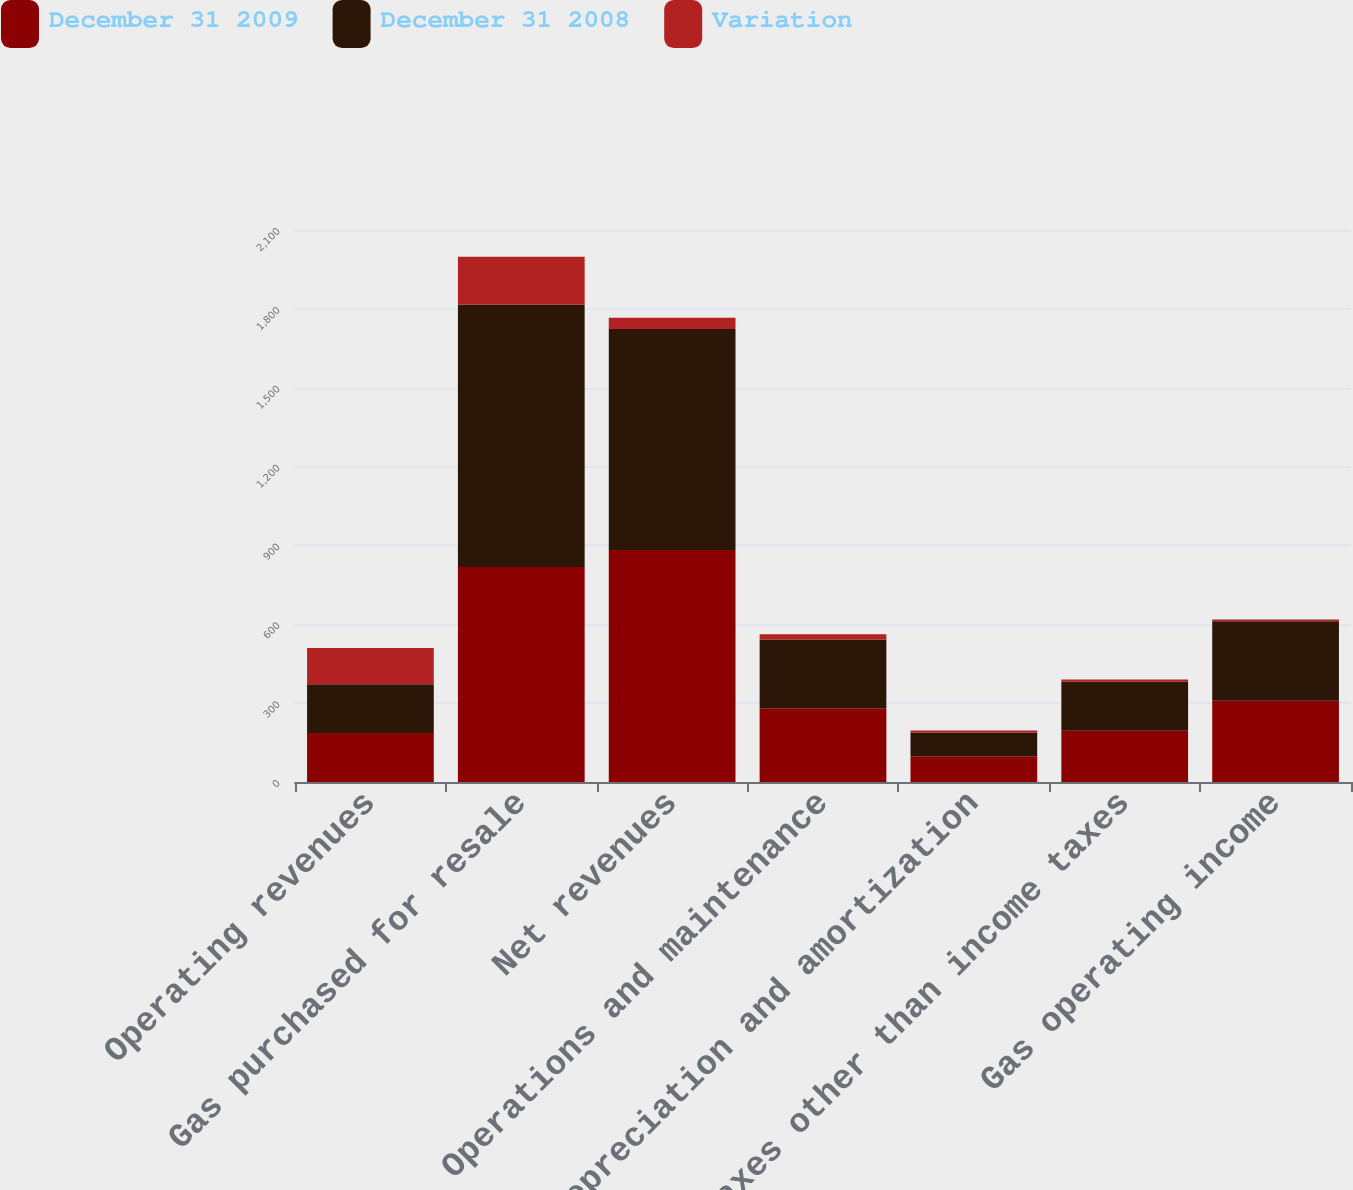Convert chart to OTSL. <chart><loc_0><loc_0><loc_500><loc_500><stacked_bar_chart><ecel><fcel>Operating revenues<fcel>Gas purchased for resale<fcel>Net revenues<fcel>Operations and maintenance<fcel>Depreciation and amortization<fcel>Taxes other than income taxes<fcel>Gas operating income<nl><fcel>December 31 2009<fcel>186<fcel>818<fcel>883<fcel>281<fcel>98<fcel>195<fcel>309<nl><fcel>December 31 2008<fcel>186<fcel>999<fcel>840<fcel>261<fcel>90<fcel>186<fcel>303<nl><fcel>Variation<fcel>138<fcel>181<fcel>43<fcel>20<fcel>8<fcel>9<fcel>6<nl></chart> 